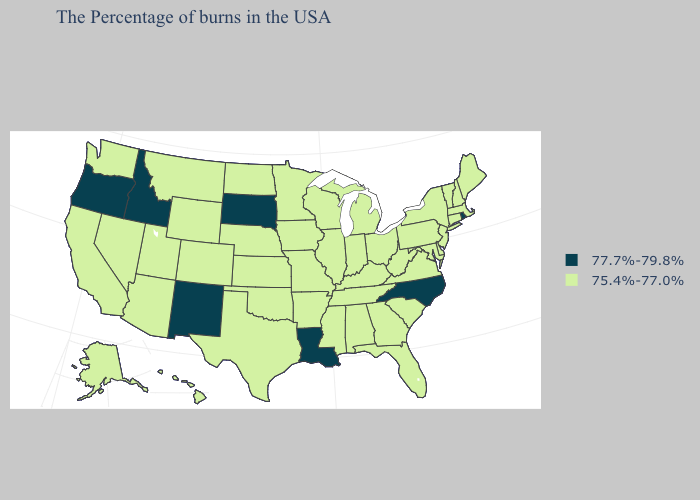Does South Dakota have the highest value in the MidWest?
Short answer required. Yes. Does Oklahoma have the lowest value in the USA?
Write a very short answer. Yes. Which states have the lowest value in the USA?
Be succinct. Maine, Massachusetts, New Hampshire, Vermont, Connecticut, New York, New Jersey, Delaware, Maryland, Pennsylvania, Virginia, South Carolina, West Virginia, Ohio, Florida, Georgia, Michigan, Kentucky, Indiana, Alabama, Tennessee, Wisconsin, Illinois, Mississippi, Missouri, Arkansas, Minnesota, Iowa, Kansas, Nebraska, Oklahoma, Texas, North Dakota, Wyoming, Colorado, Utah, Montana, Arizona, Nevada, California, Washington, Alaska, Hawaii. What is the value of Connecticut?
Give a very brief answer. 75.4%-77.0%. Does the first symbol in the legend represent the smallest category?
Answer briefly. No. What is the value of North Carolina?
Give a very brief answer. 77.7%-79.8%. Name the states that have a value in the range 75.4%-77.0%?
Concise answer only. Maine, Massachusetts, New Hampshire, Vermont, Connecticut, New York, New Jersey, Delaware, Maryland, Pennsylvania, Virginia, South Carolina, West Virginia, Ohio, Florida, Georgia, Michigan, Kentucky, Indiana, Alabama, Tennessee, Wisconsin, Illinois, Mississippi, Missouri, Arkansas, Minnesota, Iowa, Kansas, Nebraska, Oklahoma, Texas, North Dakota, Wyoming, Colorado, Utah, Montana, Arizona, Nevada, California, Washington, Alaska, Hawaii. Name the states that have a value in the range 75.4%-77.0%?
Keep it brief. Maine, Massachusetts, New Hampshire, Vermont, Connecticut, New York, New Jersey, Delaware, Maryland, Pennsylvania, Virginia, South Carolina, West Virginia, Ohio, Florida, Georgia, Michigan, Kentucky, Indiana, Alabama, Tennessee, Wisconsin, Illinois, Mississippi, Missouri, Arkansas, Minnesota, Iowa, Kansas, Nebraska, Oklahoma, Texas, North Dakota, Wyoming, Colorado, Utah, Montana, Arizona, Nevada, California, Washington, Alaska, Hawaii. Name the states that have a value in the range 75.4%-77.0%?
Write a very short answer. Maine, Massachusetts, New Hampshire, Vermont, Connecticut, New York, New Jersey, Delaware, Maryland, Pennsylvania, Virginia, South Carolina, West Virginia, Ohio, Florida, Georgia, Michigan, Kentucky, Indiana, Alabama, Tennessee, Wisconsin, Illinois, Mississippi, Missouri, Arkansas, Minnesota, Iowa, Kansas, Nebraska, Oklahoma, Texas, North Dakota, Wyoming, Colorado, Utah, Montana, Arizona, Nevada, California, Washington, Alaska, Hawaii. What is the value of Illinois?
Give a very brief answer. 75.4%-77.0%. Name the states that have a value in the range 77.7%-79.8%?
Concise answer only. Rhode Island, North Carolina, Louisiana, South Dakota, New Mexico, Idaho, Oregon. Name the states that have a value in the range 75.4%-77.0%?
Concise answer only. Maine, Massachusetts, New Hampshire, Vermont, Connecticut, New York, New Jersey, Delaware, Maryland, Pennsylvania, Virginia, South Carolina, West Virginia, Ohio, Florida, Georgia, Michigan, Kentucky, Indiana, Alabama, Tennessee, Wisconsin, Illinois, Mississippi, Missouri, Arkansas, Minnesota, Iowa, Kansas, Nebraska, Oklahoma, Texas, North Dakota, Wyoming, Colorado, Utah, Montana, Arizona, Nevada, California, Washington, Alaska, Hawaii. Does the map have missing data?
Answer briefly. No. What is the value of Minnesota?
Quick response, please. 75.4%-77.0%. 